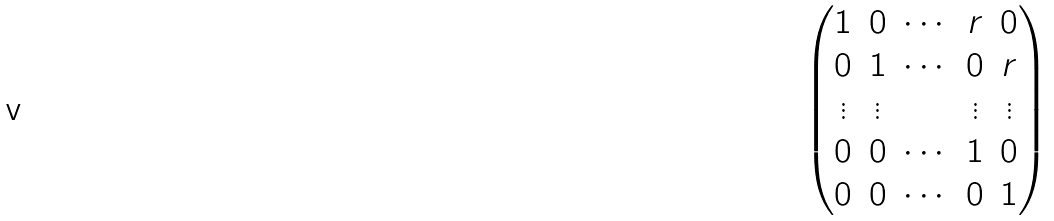Convert formula to latex. <formula><loc_0><loc_0><loc_500><loc_500>\begin{pmatrix} 1 & 0 & \cdots & r & 0 \\ 0 & 1 & \cdots & 0 & r \\ \vdots & \vdots & & \vdots & \vdots \\ 0 & 0 & \cdots & 1 & 0 \\ 0 & 0 & \cdots & 0 & 1 \end{pmatrix}</formula> 